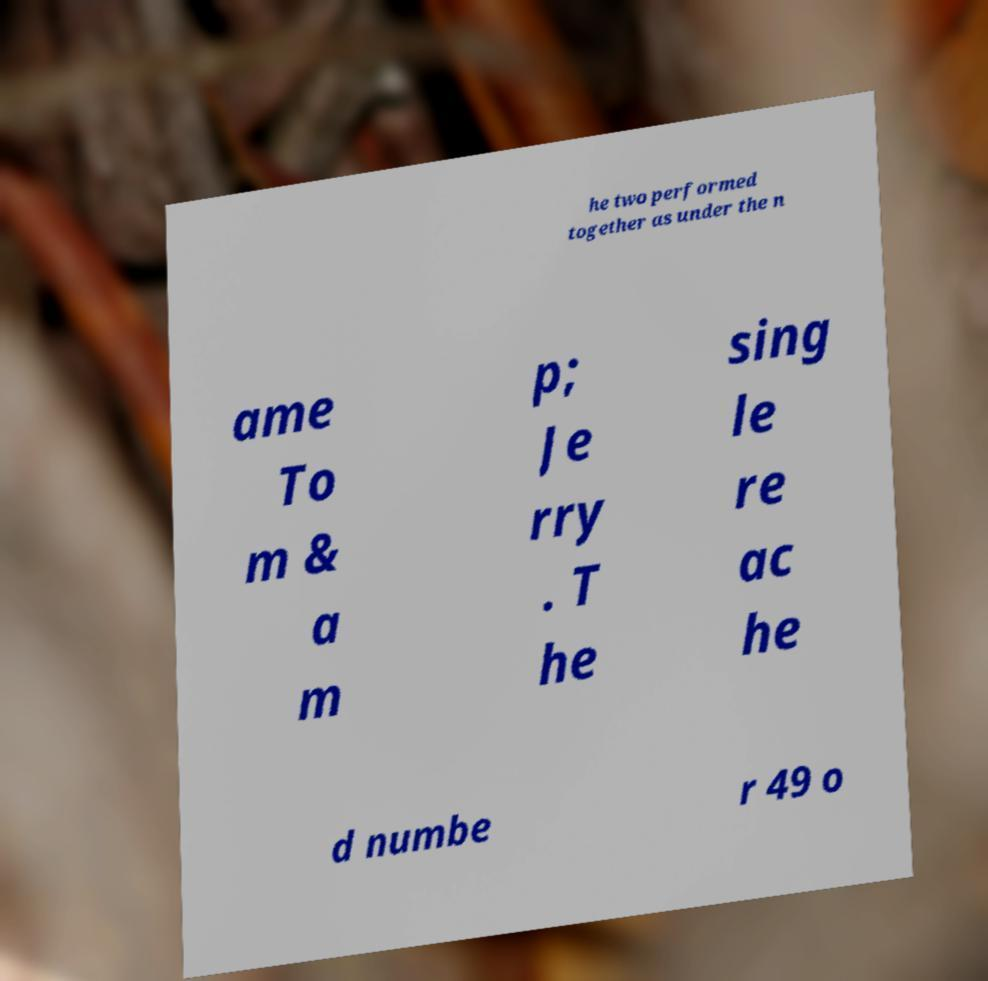Can you accurately transcribe the text from the provided image for me? he two performed together as under the n ame To m & a m p; Je rry . T he sing le re ac he d numbe r 49 o 